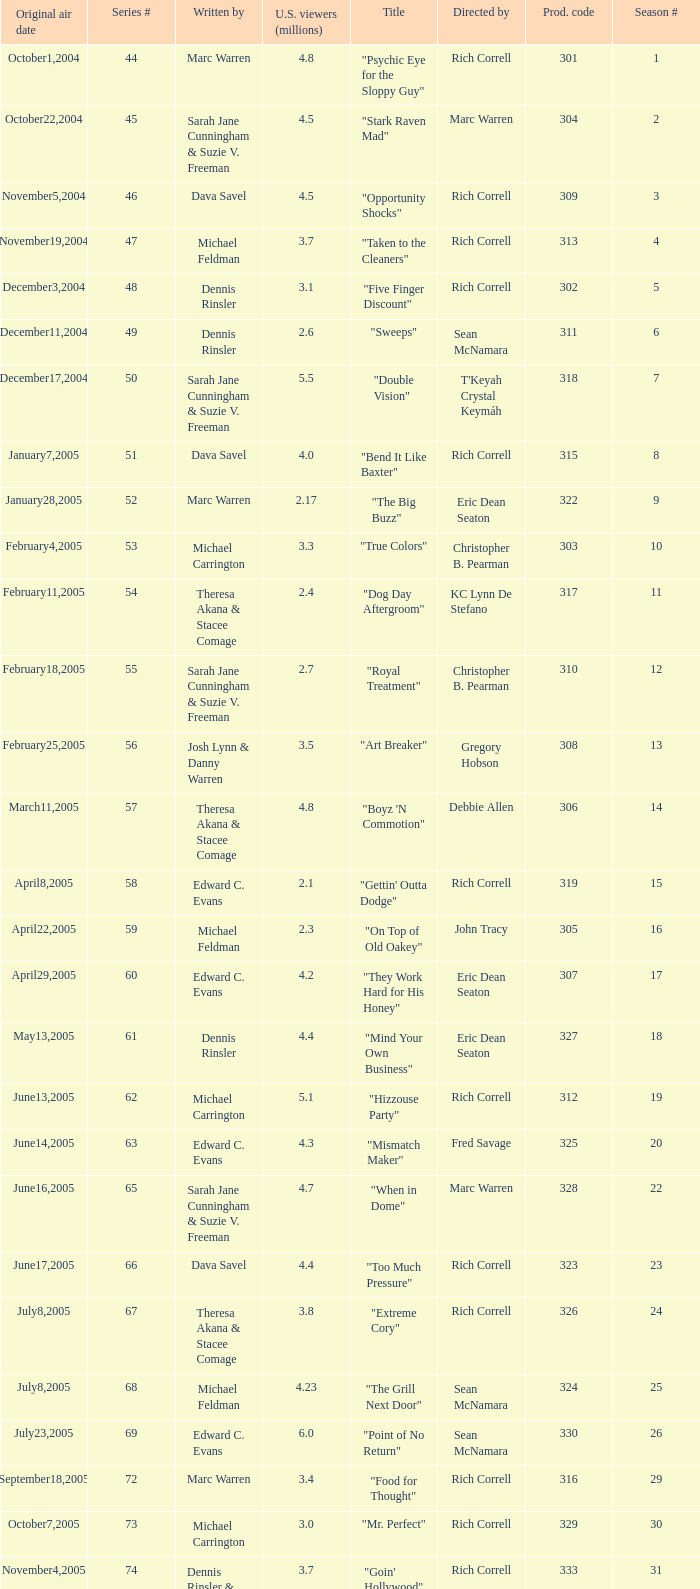What is the title of the episode directed by Rich Correll and written by Dennis Rinsler? "Five Finger Discount". 